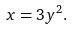Convert formula to latex. <formula><loc_0><loc_0><loc_500><loc_500>x = 3 y ^ { 2 } .</formula> 